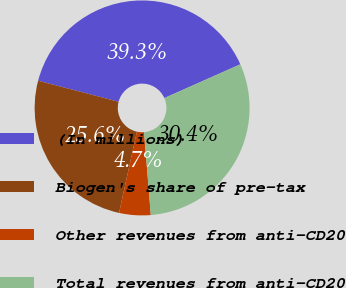Convert chart. <chart><loc_0><loc_0><loc_500><loc_500><pie_chart><fcel>(In millions)<fcel>Biogen's share of pre-tax<fcel>Other revenues from anti-CD20<fcel>Total revenues from anti-CD20<nl><fcel>39.28%<fcel>25.63%<fcel>4.73%<fcel>30.36%<nl></chart> 